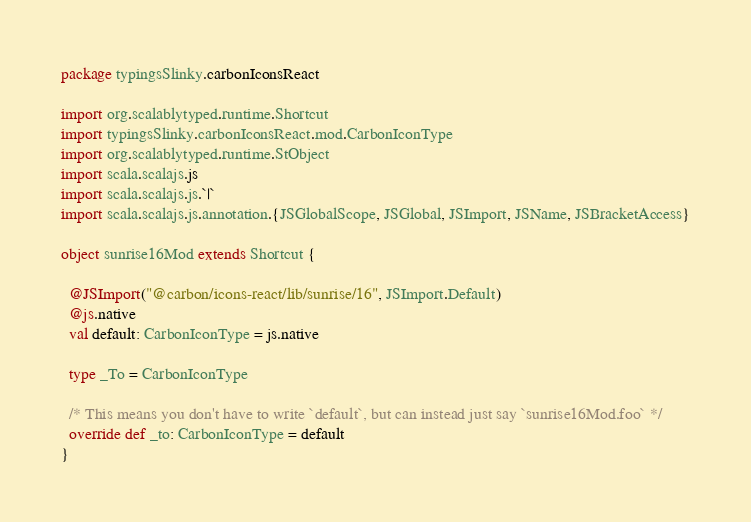<code> <loc_0><loc_0><loc_500><loc_500><_Scala_>package typingsSlinky.carbonIconsReact

import org.scalablytyped.runtime.Shortcut
import typingsSlinky.carbonIconsReact.mod.CarbonIconType
import org.scalablytyped.runtime.StObject
import scala.scalajs.js
import scala.scalajs.js.`|`
import scala.scalajs.js.annotation.{JSGlobalScope, JSGlobal, JSImport, JSName, JSBracketAccess}

object sunrise16Mod extends Shortcut {
  
  @JSImport("@carbon/icons-react/lib/sunrise/16", JSImport.Default)
  @js.native
  val default: CarbonIconType = js.native
  
  type _To = CarbonIconType
  
  /* This means you don't have to write `default`, but can instead just say `sunrise16Mod.foo` */
  override def _to: CarbonIconType = default
}
</code> 